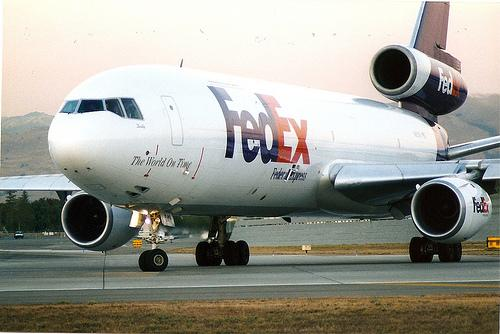What is the color of the FedEx logo and where is it positioned on the plane? The FedEx logo is orange and brown in color and is positioned on the middle side of the plane. What sentiment does this image convey? The image conveys a neutral sentiment as it showcases a plane parked on a runway, a routine and unemotional scene. Rate the image quality on a scale of 1 to 5, with 5 being excellent and 1 being poor. I'd rate the image quality as a 4, as it appears to be clear and detailed, but there could be room for improvement. Briefly describe the surroundings of the plane found in the image. The plane is surrounded by a runway, dead grass, a building in the background, and mountains in the distance against a pink sky. Can you identify the primary object in the picture and mention its purpose? The primary object in the picture is a FedEx plane, which is used for mail delivery. How many jet engines can be seen in the image and where are they located? Three jet engines are visible in the image: one on the back, one on the left wing, and one on the right wing. Name all object types that the image provided in relation to the plane. Jet engines, landing gears, loading door, cockpit windscreen, tail section, nose section, plane's door, FedEx logo, plane wing, entrance door, and front wheels. What type of reasoning skills would be necessary to determine if the plane is parked or preparing for takeoff? Complex reasoning skills, which require analyzing different elements in the image and deducing the plane's state based on factors such as landing gear position and engine activity. Please provide a brief description of the whole scene in the image. The image shows a FedEx plane parked on a runway with its landing gears down and engines visible, mountains in the distance, a building in the background, and dead grass surrounding the area. Count the total number of visible wheels on the plane in the picture. There are a total of six visible wheels on the plane: four rear landing gears and two front landing gears. 